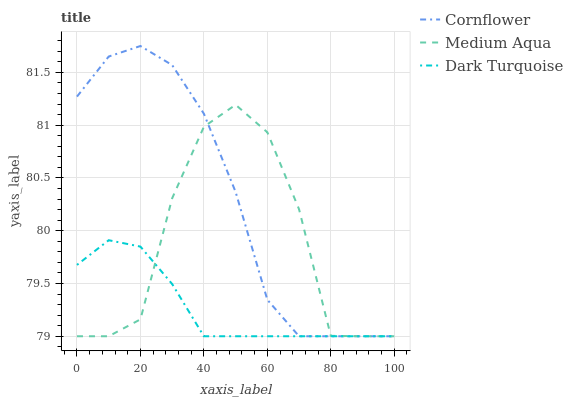Does Dark Turquoise have the minimum area under the curve?
Answer yes or no. Yes. Does Cornflower have the maximum area under the curve?
Answer yes or no. Yes. Does Medium Aqua have the minimum area under the curve?
Answer yes or no. No. Does Medium Aqua have the maximum area under the curve?
Answer yes or no. No. Is Dark Turquoise the smoothest?
Answer yes or no. Yes. Is Medium Aqua the roughest?
Answer yes or no. Yes. Is Medium Aqua the smoothest?
Answer yes or no. No. Is Dark Turquoise the roughest?
Answer yes or no. No. Does Cornflower have the lowest value?
Answer yes or no. Yes. Does Cornflower have the highest value?
Answer yes or no. Yes. Does Medium Aqua have the highest value?
Answer yes or no. No. Does Medium Aqua intersect Cornflower?
Answer yes or no. Yes. Is Medium Aqua less than Cornflower?
Answer yes or no. No. Is Medium Aqua greater than Cornflower?
Answer yes or no. No. 